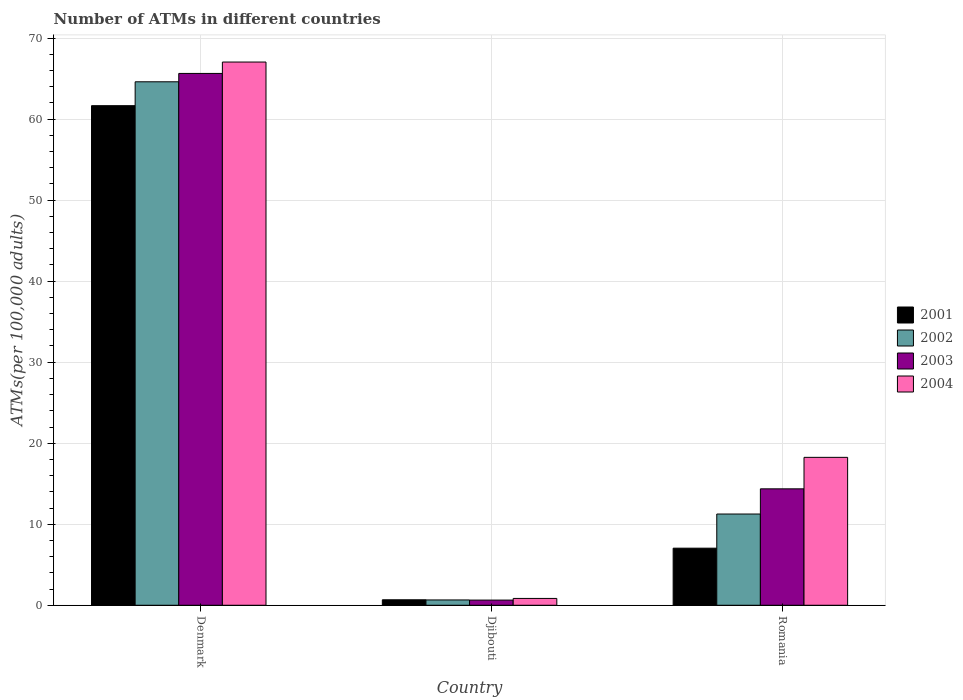How many different coloured bars are there?
Your answer should be very brief. 4. How many groups of bars are there?
Keep it short and to the point. 3. Are the number of bars per tick equal to the number of legend labels?
Your response must be concise. Yes. In how many cases, is the number of bars for a given country not equal to the number of legend labels?
Offer a very short reply. 0. What is the number of ATMs in 2003 in Denmark?
Provide a short and direct response. 65.64. Across all countries, what is the maximum number of ATMs in 2002?
Your answer should be very brief. 64.61. Across all countries, what is the minimum number of ATMs in 2002?
Offer a terse response. 0.66. In which country was the number of ATMs in 2003 minimum?
Provide a succinct answer. Djibouti. What is the total number of ATMs in 2001 in the graph?
Your response must be concise. 69.38. What is the difference between the number of ATMs in 2003 in Denmark and that in Romania?
Provide a short and direct response. 51.27. What is the difference between the number of ATMs in 2004 in Denmark and the number of ATMs in 2002 in Romania?
Your response must be concise. 55.78. What is the average number of ATMs in 2003 per country?
Make the answer very short. 26.88. What is the difference between the number of ATMs of/in 2001 and number of ATMs of/in 2002 in Romania?
Offer a very short reply. -4.21. In how many countries, is the number of ATMs in 2003 greater than 52?
Offer a very short reply. 1. What is the ratio of the number of ATMs in 2004 in Djibouti to that in Romania?
Provide a succinct answer. 0.05. Is the number of ATMs in 2003 in Djibouti less than that in Romania?
Your response must be concise. Yes. What is the difference between the highest and the second highest number of ATMs in 2002?
Provide a short and direct response. 63.95. What is the difference between the highest and the lowest number of ATMs in 2004?
Offer a terse response. 66.2. Is it the case that in every country, the sum of the number of ATMs in 2003 and number of ATMs in 2004 is greater than the number of ATMs in 2002?
Provide a succinct answer. Yes. How many bars are there?
Your answer should be very brief. 12. How many countries are there in the graph?
Offer a terse response. 3. What is the difference between two consecutive major ticks on the Y-axis?
Your answer should be compact. 10. Where does the legend appear in the graph?
Keep it short and to the point. Center right. How are the legend labels stacked?
Offer a very short reply. Vertical. What is the title of the graph?
Ensure brevity in your answer.  Number of ATMs in different countries. What is the label or title of the X-axis?
Your answer should be very brief. Country. What is the label or title of the Y-axis?
Provide a succinct answer. ATMs(per 100,0 adults). What is the ATMs(per 100,000 adults) of 2001 in Denmark?
Offer a very short reply. 61.66. What is the ATMs(per 100,000 adults) of 2002 in Denmark?
Offer a terse response. 64.61. What is the ATMs(per 100,000 adults) of 2003 in Denmark?
Ensure brevity in your answer.  65.64. What is the ATMs(per 100,000 adults) of 2004 in Denmark?
Ensure brevity in your answer.  67.04. What is the ATMs(per 100,000 adults) in 2001 in Djibouti?
Your answer should be compact. 0.68. What is the ATMs(per 100,000 adults) of 2002 in Djibouti?
Give a very brief answer. 0.66. What is the ATMs(per 100,000 adults) in 2003 in Djibouti?
Keep it short and to the point. 0.64. What is the ATMs(per 100,000 adults) of 2004 in Djibouti?
Provide a short and direct response. 0.84. What is the ATMs(per 100,000 adults) of 2001 in Romania?
Ensure brevity in your answer.  7.04. What is the ATMs(per 100,000 adults) of 2002 in Romania?
Offer a terse response. 11.26. What is the ATMs(per 100,000 adults) in 2003 in Romania?
Provide a succinct answer. 14.37. What is the ATMs(per 100,000 adults) of 2004 in Romania?
Your answer should be compact. 18.26. Across all countries, what is the maximum ATMs(per 100,000 adults) of 2001?
Provide a succinct answer. 61.66. Across all countries, what is the maximum ATMs(per 100,000 adults) in 2002?
Keep it short and to the point. 64.61. Across all countries, what is the maximum ATMs(per 100,000 adults) of 2003?
Your answer should be very brief. 65.64. Across all countries, what is the maximum ATMs(per 100,000 adults) of 2004?
Offer a very short reply. 67.04. Across all countries, what is the minimum ATMs(per 100,000 adults) in 2001?
Keep it short and to the point. 0.68. Across all countries, what is the minimum ATMs(per 100,000 adults) in 2002?
Your answer should be compact. 0.66. Across all countries, what is the minimum ATMs(per 100,000 adults) of 2003?
Offer a very short reply. 0.64. Across all countries, what is the minimum ATMs(per 100,000 adults) in 2004?
Your answer should be compact. 0.84. What is the total ATMs(per 100,000 adults) in 2001 in the graph?
Provide a succinct answer. 69.38. What is the total ATMs(per 100,000 adults) of 2002 in the graph?
Keep it short and to the point. 76.52. What is the total ATMs(per 100,000 adults) of 2003 in the graph?
Your answer should be very brief. 80.65. What is the total ATMs(per 100,000 adults) in 2004 in the graph?
Offer a very short reply. 86.14. What is the difference between the ATMs(per 100,000 adults) in 2001 in Denmark and that in Djibouti?
Ensure brevity in your answer.  60.98. What is the difference between the ATMs(per 100,000 adults) in 2002 in Denmark and that in Djibouti?
Offer a very short reply. 63.95. What is the difference between the ATMs(per 100,000 adults) in 2003 in Denmark and that in Djibouti?
Your response must be concise. 65. What is the difference between the ATMs(per 100,000 adults) in 2004 in Denmark and that in Djibouti?
Make the answer very short. 66.2. What is the difference between the ATMs(per 100,000 adults) of 2001 in Denmark and that in Romania?
Offer a terse response. 54.61. What is the difference between the ATMs(per 100,000 adults) of 2002 in Denmark and that in Romania?
Provide a short and direct response. 53.35. What is the difference between the ATMs(per 100,000 adults) in 2003 in Denmark and that in Romania?
Your response must be concise. 51.27. What is the difference between the ATMs(per 100,000 adults) in 2004 in Denmark and that in Romania?
Keep it short and to the point. 48.79. What is the difference between the ATMs(per 100,000 adults) of 2001 in Djibouti and that in Romania?
Offer a very short reply. -6.37. What is the difference between the ATMs(per 100,000 adults) in 2002 in Djibouti and that in Romania?
Offer a terse response. -10.6. What is the difference between the ATMs(per 100,000 adults) of 2003 in Djibouti and that in Romania?
Provide a succinct answer. -13.73. What is the difference between the ATMs(per 100,000 adults) of 2004 in Djibouti and that in Romania?
Provide a short and direct response. -17.41. What is the difference between the ATMs(per 100,000 adults) in 2001 in Denmark and the ATMs(per 100,000 adults) in 2002 in Djibouti?
Provide a short and direct response. 61. What is the difference between the ATMs(per 100,000 adults) of 2001 in Denmark and the ATMs(per 100,000 adults) of 2003 in Djibouti?
Make the answer very short. 61.02. What is the difference between the ATMs(per 100,000 adults) of 2001 in Denmark and the ATMs(per 100,000 adults) of 2004 in Djibouti?
Your answer should be compact. 60.81. What is the difference between the ATMs(per 100,000 adults) in 2002 in Denmark and the ATMs(per 100,000 adults) in 2003 in Djibouti?
Your response must be concise. 63.97. What is the difference between the ATMs(per 100,000 adults) of 2002 in Denmark and the ATMs(per 100,000 adults) of 2004 in Djibouti?
Provide a short and direct response. 63.76. What is the difference between the ATMs(per 100,000 adults) of 2003 in Denmark and the ATMs(per 100,000 adults) of 2004 in Djibouti?
Your response must be concise. 64.79. What is the difference between the ATMs(per 100,000 adults) in 2001 in Denmark and the ATMs(per 100,000 adults) in 2002 in Romania?
Provide a short and direct response. 50.4. What is the difference between the ATMs(per 100,000 adults) in 2001 in Denmark and the ATMs(per 100,000 adults) in 2003 in Romania?
Your answer should be compact. 47.29. What is the difference between the ATMs(per 100,000 adults) in 2001 in Denmark and the ATMs(per 100,000 adults) in 2004 in Romania?
Your answer should be very brief. 43.4. What is the difference between the ATMs(per 100,000 adults) of 2002 in Denmark and the ATMs(per 100,000 adults) of 2003 in Romania?
Your answer should be compact. 50.24. What is the difference between the ATMs(per 100,000 adults) in 2002 in Denmark and the ATMs(per 100,000 adults) in 2004 in Romania?
Provide a short and direct response. 46.35. What is the difference between the ATMs(per 100,000 adults) of 2003 in Denmark and the ATMs(per 100,000 adults) of 2004 in Romania?
Your response must be concise. 47.38. What is the difference between the ATMs(per 100,000 adults) in 2001 in Djibouti and the ATMs(per 100,000 adults) in 2002 in Romania?
Your answer should be compact. -10.58. What is the difference between the ATMs(per 100,000 adults) of 2001 in Djibouti and the ATMs(per 100,000 adults) of 2003 in Romania?
Make the answer very short. -13.69. What is the difference between the ATMs(per 100,000 adults) of 2001 in Djibouti and the ATMs(per 100,000 adults) of 2004 in Romania?
Give a very brief answer. -17.58. What is the difference between the ATMs(per 100,000 adults) in 2002 in Djibouti and the ATMs(per 100,000 adults) in 2003 in Romania?
Offer a very short reply. -13.71. What is the difference between the ATMs(per 100,000 adults) of 2002 in Djibouti and the ATMs(per 100,000 adults) of 2004 in Romania?
Ensure brevity in your answer.  -17.6. What is the difference between the ATMs(per 100,000 adults) in 2003 in Djibouti and the ATMs(per 100,000 adults) in 2004 in Romania?
Offer a terse response. -17.62. What is the average ATMs(per 100,000 adults) of 2001 per country?
Make the answer very short. 23.13. What is the average ATMs(per 100,000 adults) in 2002 per country?
Provide a succinct answer. 25.51. What is the average ATMs(per 100,000 adults) in 2003 per country?
Ensure brevity in your answer.  26.88. What is the average ATMs(per 100,000 adults) of 2004 per country?
Offer a very short reply. 28.71. What is the difference between the ATMs(per 100,000 adults) in 2001 and ATMs(per 100,000 adults) in 2002 in Denmark?
Your response must be concise. -2.95. What is the difference between the ATMs(per 100,000 adults) in 2001 and ATMs(per 100,000 adults) in 2003 in Denmark?
Give a very brief answer. -3.98. What is the difference between the ATMs(per 100,000 adults) of 2001 and ATMs(per 100,000 adults) of 2004 in Denmark?
Ensure brevity in your answer.  -5.39. What is the difference between the ATMs(per 100,000 adults) in 2002 and ATMs(per 100,000 adults) in 2003 in Denmark?
Your response must be concise. -1.03. What is the difference between the ATMs(per 100,000 adults) of 2002 and ATMs(per 100,000 adults) of 2004 in Denmark?
Provide a succinct answer. -2.44. What is the difference between the ATMs(per 100,000 adults) in 2003 and ATMs(per 100,000 adults) in 2004 in Denmark?
Your answer should be compact. -1.41. What is the difference between the ATMs(per 100,000 adults) in 2001 and ATMs(per 100,000 adults) in 2002 in Djibouti?
Offer a very short reply. 0.02. What is the difference between the ATMs(per 100,000 adults) in 2001 and ATMs(per 100,000 adults) in 2003 in Djibouti?
Provide a short and direct response. 0.04. What is the difference between the ATMs(per 100,000 adults) of 2001 and ATMs(per 100,000 adults) of 2004 in Djibouti?
Keep it short and to the point. -0.17. What is the difference between the ATMs(per 100,000 adults) of 2002 and ATMs(per 100,000 adults) of 2003 in Djibouti?
Keep it short and to the point. 0.02. What is the difference between the ATMs(per 100,000 adults) in 2002 and ATMs(per 100,000 adults) in 2004 in Djibouti?
Keep it short and to the point. -0.19. What is the difference between the ATMs(per 100,000 adults) of 2003 and ATMs(per 100,000 adults) of 2004 in Djibouti?
Offer a very short reply. -0.21. What is the difference between the ATMs(per 100,000 adults) in 2001 and ATMs(per 100,000 adults) in 2002 in Romania?
Ensure brevity in your answer.  -4.21. What is the difference between the ATMs(per 100,000 adults) in 2001 and ATMs(per 100,000 adults) in 2003 in Romania?
Provide a succinct answer. -7.32. What is the difference between the ATMs(per 100,000 adults) in 2001 and ATMs(per 100,000 adults) in 2004 in Romania?
Make the answer very short. -11.21. What is the difference between the ATMs(per 100,000 adults) of 2002 and ATMs(per 100,000 adults) of 2003 in Romania?
Your answer should be very brief. -3.11. What is the difference between the ATMs(per 100,000 adults) of 2002 and ATMs(per 100,000 adults) of 2004 in Romania?
Give a very brief answer. -7. What is the difference between the ATMs(per 100,000 adults) of 2003 and ATMs(per 100,000 adults) of 2004 in Romania?
Offer a very short reply. -3.89. What is the ratio of the ATMs(per 100,000 adults) of 2001 in Denmark to that in Djibouti?
Offer a very short reply. 91.18. What is the ratio of the ATMs(per 100,000 adults) in 2002 in Denmark to that in Djibouti?
Provide a short and direct response. 98.45. What is the ratio of the ATMs(per 100,000 adults) of 2003 in Denmark to that in Djibouti?
Your answer should be very brief. 102.88. What is the ratio of the ATMs(per 100,000 adults) in 2004 in Denmark to that in Djibouti?
Offer a terse response. 79.46. What is the ratio of the ATMs(per 100,000 adults) of 2001 in Denmark to that in Romania?
Give a very brief answer. 8.75. What is the ratio of the ATMs(per 100,000 adults) in 2002 in Denmark to that in Romania?
Your response must be concise. 5.74. What is the ratio of the ATMs(per 100,000 adults) in 2003 in Denmark to that in Romania?
Make the answer very short. 4.57. What is the ratio of the ATMs(per 100,000 adults) in 2004 in Denmark to that in Romania?
Provide a succinct answer. 3.67. What is the ratio of the ATMs(per 100,000 adults) of 2001 in Djibouti to that in Romania?
Your response must be concise. 0.1. What is the ratio of the ATMs(per 100,000 adults) of 2002 in Djibouti to that in Romania?
Keep it short and to the point. 0.06. What is the ratio of the ATMs(per 100,000 adults) in 2003 in Djibouti to that in Romania?
Make the answer very short. 0.04. What is the ratio of the ATMs(per 100,000 adults) of 2004 in Djibouti to that in Romania?
Offer a terse response. 0.05. What is the difference between the highest and the second highest ATMs(per 100,000 adults) of 2001?
Make the answer very short. 54.61. What is the difference between the highest and the second highest ATMs(per 100,000 adults) of 2002?
Make the answer very short. 53.35. What is the difference between the highest and the second highest ATMs(per 100,000 adults) in 2003?
Offer a very short reply. 51.27. What is the difference between the highest and the second highest ATMs(per 100,000 adults) in 2004?
Your response must be concise. 48.79. What is the difference between the highest and the lowest ATMs(per 100,000 adults) in 2001?
Your answer should be very brief. 60.98. What is the difference between the highest and the lowest ATMs(per 100,000 adults) in 2002?
Your answer should be very brief. 63.95. What is the difference between the highest and the lowest ATMs(per 100,000 adults) in 2003?
Provide a succinct answer. 65. What is the difference between the highest and the lowest ATMs(per 100,000 adults) of 2004?
Ensure brevity in your answer.  66.2. 